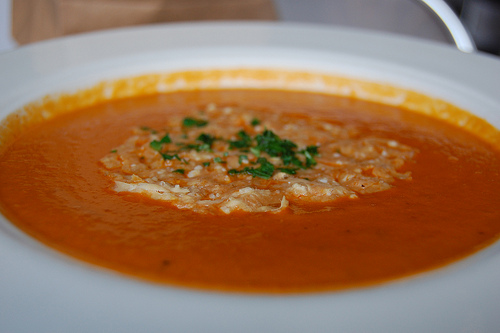<image>
Is there a cheese in the bowl? Yes. The cheese is contained within or inside the bowl, showing a containment relationship. 